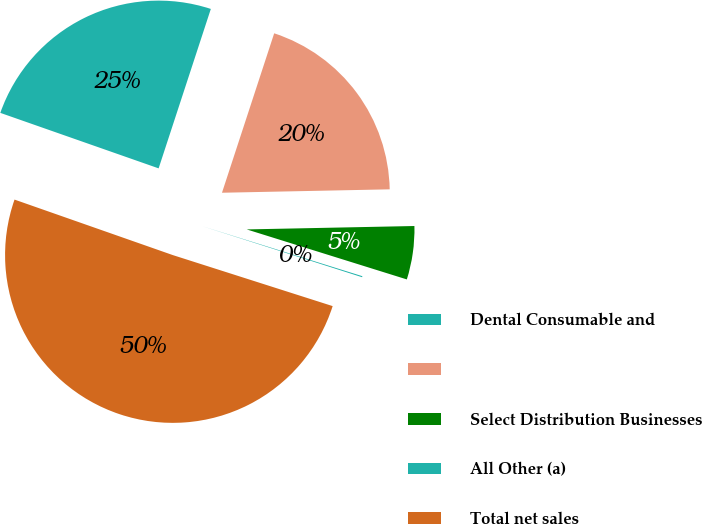Convert chart to OTSL. <chart><loc_0><loc_0><loc_500><loc_500><pie_chart><fcel>Dental Consumable and<fcel>Unnamed: 1<fcel>Select Distribution Businesses<fcel>All Other (a)<fcel>Total net sales<nl><fcel>24.67%<fcel>19.64%<fcel>5.14%<fcel>0.1%<fcel>50.45%<nl></chart> 